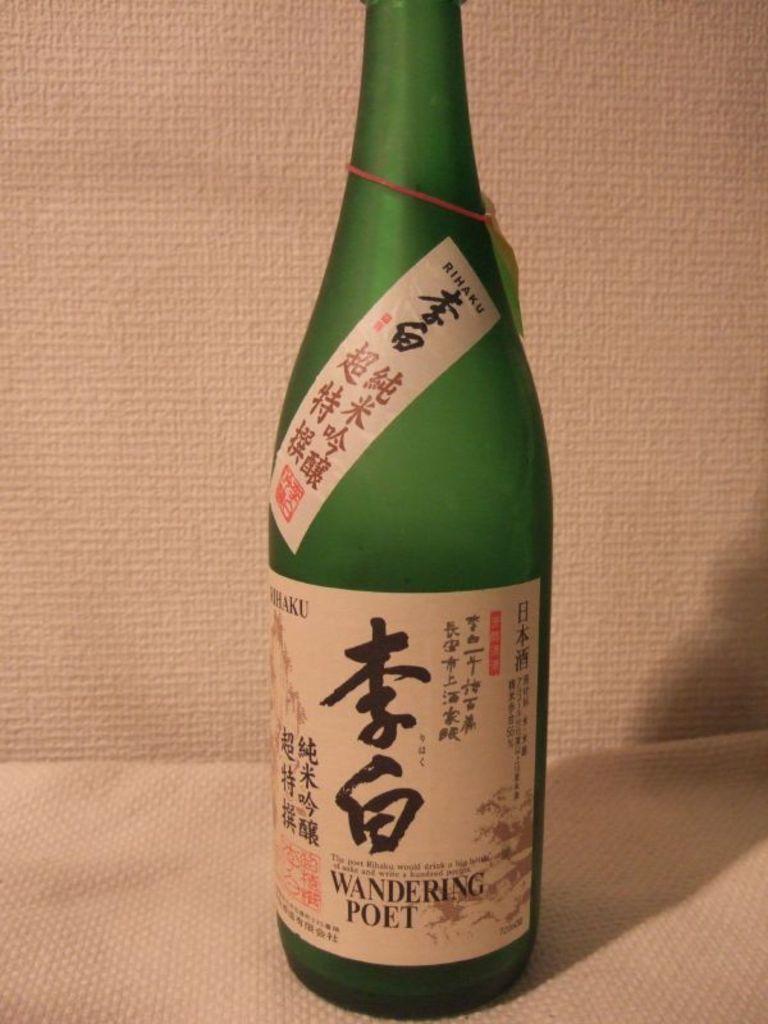Describe this image in one or two sentences. In this image, we can see a green bottle with stickers and tag is placed on the white surface. Background we can see white color. 